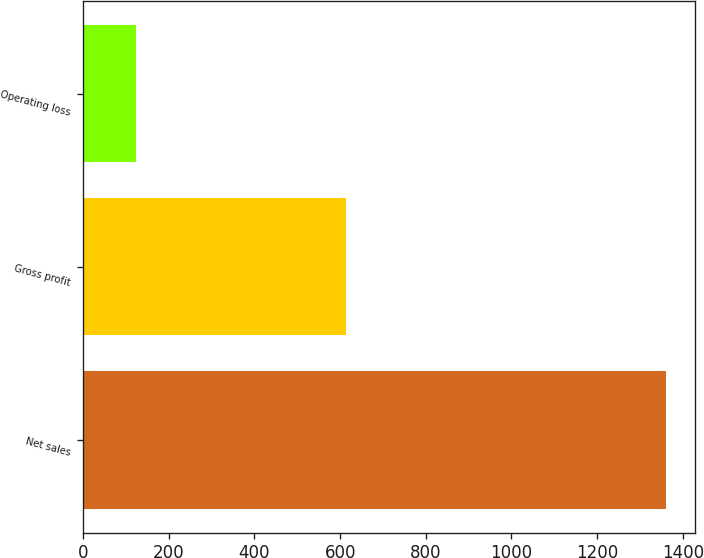Convert chart. <chart><loc_0><loc_0><loc_500><loc_500><bar_chart><fcel>Net sales<fcel>Gross profit<fcel>Operating loss<nl><fcel>1360.6<fcel>614.7<fcel>124.3<nl></chart> 